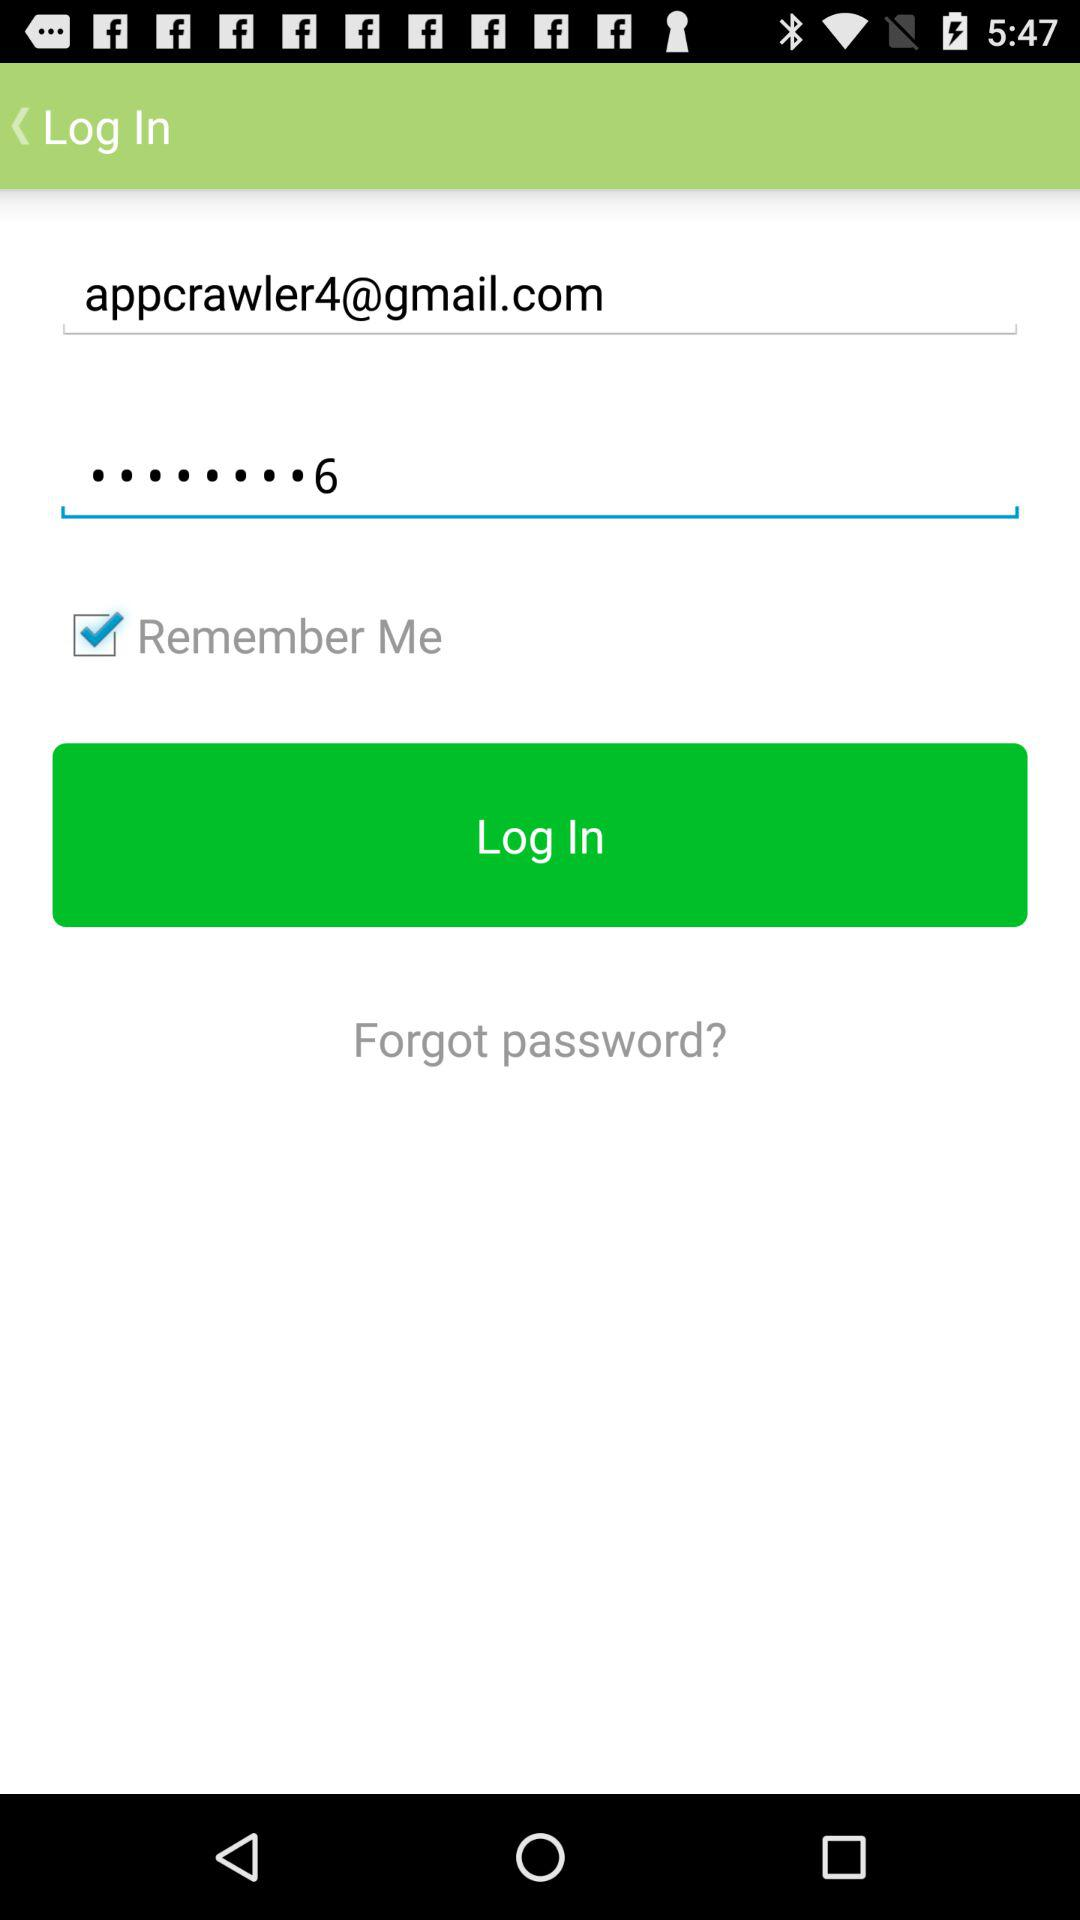What is the status of "Remember Me"? The status is "on". 